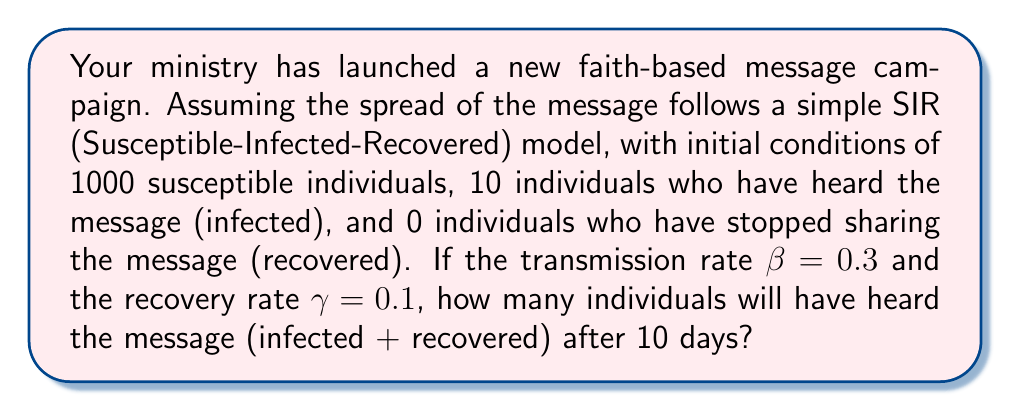Help me with this question. To solve this problem, we'll use the SIR model equations and numerical integration:

1) The SIR model equations are:

   $$\frac{dS}{dt} = -\beta SI$$
   $$\frac{dI}{dt} = \beta SI - \gamma I$$
   $$\frac{dR}{dt} = \gamma I$$

   Where S is susceptible, I is infected (heard the message), and R is recovered.

2) Initial conditions: S(0) = 1000, I(0) = 10, R(0) = 0

3) We'll use the Euler method for numerical integration with a time step of 0.1 days:

   $$S_{t+1} = S_t - 0.1 \beta S_t I_t$$
   $$I_{t+1} = I_t + 0.1 (\beta S_t I_t - \gamma I_t)$$
   $$R_{t+1} = R_t + 0.1 \gamma I_t$$

4) Implement this in a loop for 100 steps (10 days):

   ```python
   S, I, R = 1000, 10, 0
   beta, gamma = 0.3, 0.1
   dt = 0.1

   for _ in range(100):
       dS = -beta * S * I * dt
       dI = (beta * S * I - gamma * I) * dt
       dR = gamma * I * dt
       S += dS
       I += dI
       R += dR
   ```

5) After the loop, I + R will give the total number of individuals who have heard the message.
Answer: After 10 days, approximately 725 individuals will have heard the message (infected + recovered). 